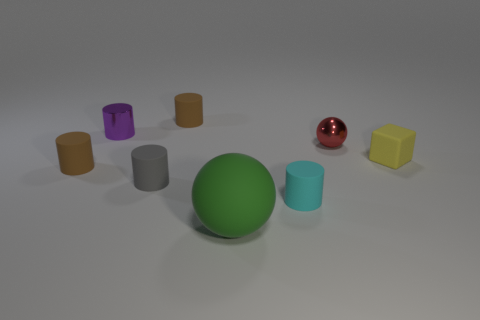Subtract all cyan cylinders. How many cylinders are left? 4 Subtract all tiny metallic cylinders. How many cylinders are left? 4 Subtract all red cylinders. Subtract all purple balls. How many cylinders are left? 5 Add 2 tiny purple matte cubes. How many objects exist? 10 Subtract all cylinders. How many objects are left? 3 Subtract all blue matte spheres. Subtract all cubes. How many objects are left? 7 Add 3 small cyan cylinders. How many small cyan cylinders are left? 4 Add 5 tiny yellow things. How many tiny yellow things exist? 6 Subtract 0 red blocks. How many objects are left? 8 